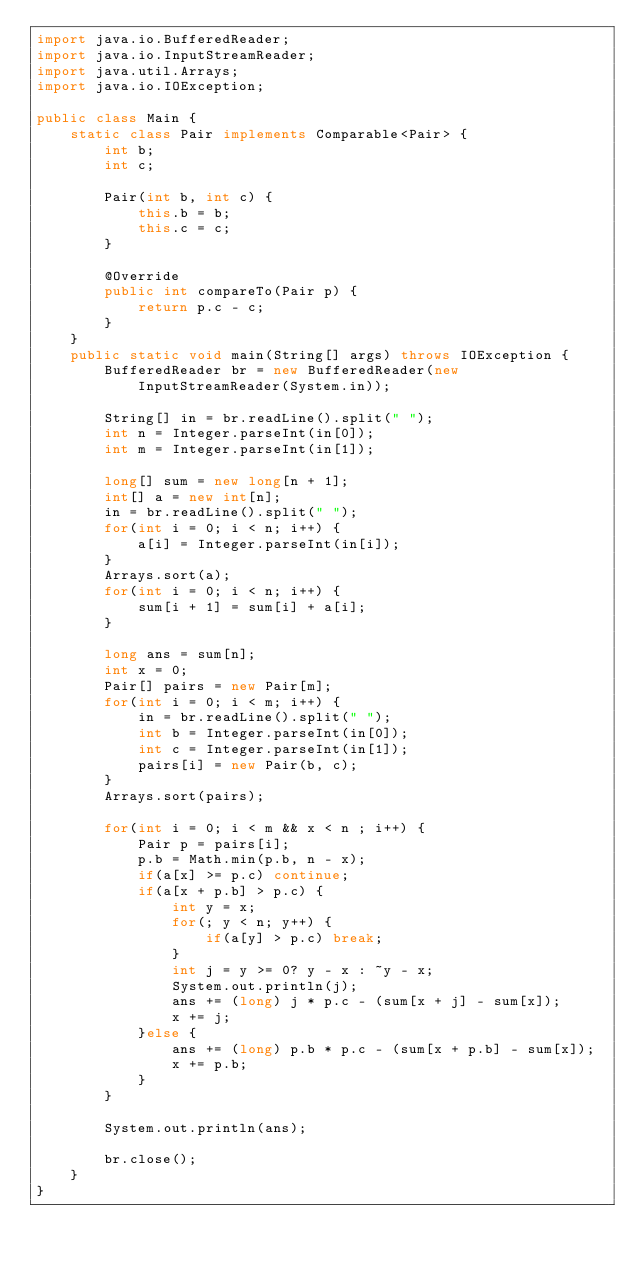<code> <loc_0><loc_0><loc_500><loc_500><_Java_>import java.io.BufferedReader;
import java.io.InputStreamReader;
import java.util.Arrays;
import java.io.IOException;

public class Main {
    static class Pair implements Comparable<Pair> {
        int b;
        int c;

        Pair(int b, int c) {
            this.b = b;
            this.c = c;
        }

        @Override
        public int compareTo(Pair p) {
            return p.c - c;
        }
    }
    public static void main(String[] args) throws IOException {
        BufferedReader br = new BufferedReader(new InputStreamReader(System.in));

        String[] in = br.readLine().split(" ");
        int n = Integer.parseInt(in[0]);
        int m = Integer.parseInt(in[1]);

        long[] sum = new long[n + 1];
        int[] a = new int[n];
        in = br.readLine().split(" ");
        for(int i = 0; i < n; i++) {
            a[i] = Integer.parseInt(in[i]);
        }
        Arrays.sort(a);
        for(int i = 0; i < n; i++) {
            sum[i + 1] = sum[i] + a[i];
        }

        long ans = sum[n];
        int x = 0;
        Pair[] pairs = new Pair[m];
        for(int i = 0; i < m; i++) {
            in = br.readLine().split(" ");
            int b = Integer.parseInt(in[0]);
            int c = Integer.parseInt(in[1]);
            pairs[i] = new Pair(b, c);
        }
        Arrays.sort(pairs);

        for(int i = 0; i < m && x < n ; i++) {
            Pair p = pairs[i];
            p.b = Math.min(p.b, n - x);
            if(a[x] >= p.c) continue;
            if(a[x + p.b] > p.c) {
                int y = x;
                for(; y < n; y++) {
                    if(a[y] > p.c) break;
                }
                int j = y >= 0? y - x : ~y - x;
                System.out.println(j);
                ans += (long) j * p.c - (sum[x + j] - sum[x]);
                x += j;
            }else {
                ans += (long) p.b * p.c - (sum[x + p.b] - sum[x]);
                x += p.b;
            }
        }

        System.out.println(ans);

        br.close();
    }
}</code> 